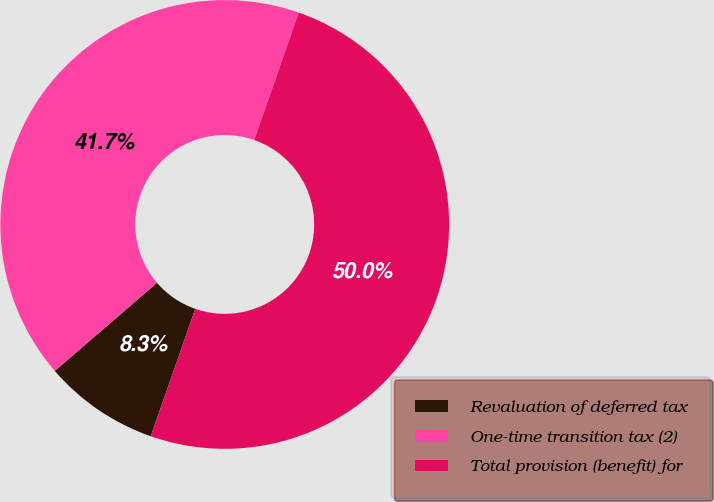Convert chart. <chart><loc_0><loc_0><loc_500><loc_500><pie_chart><fcel>Revaluation of deferred tax<fcel>One-time transition tax (2)<fcel>Total provision (benefit) for<nl><fcel>8.33%<fcel>41.67%<fcel>50.0%<nl></chart> 